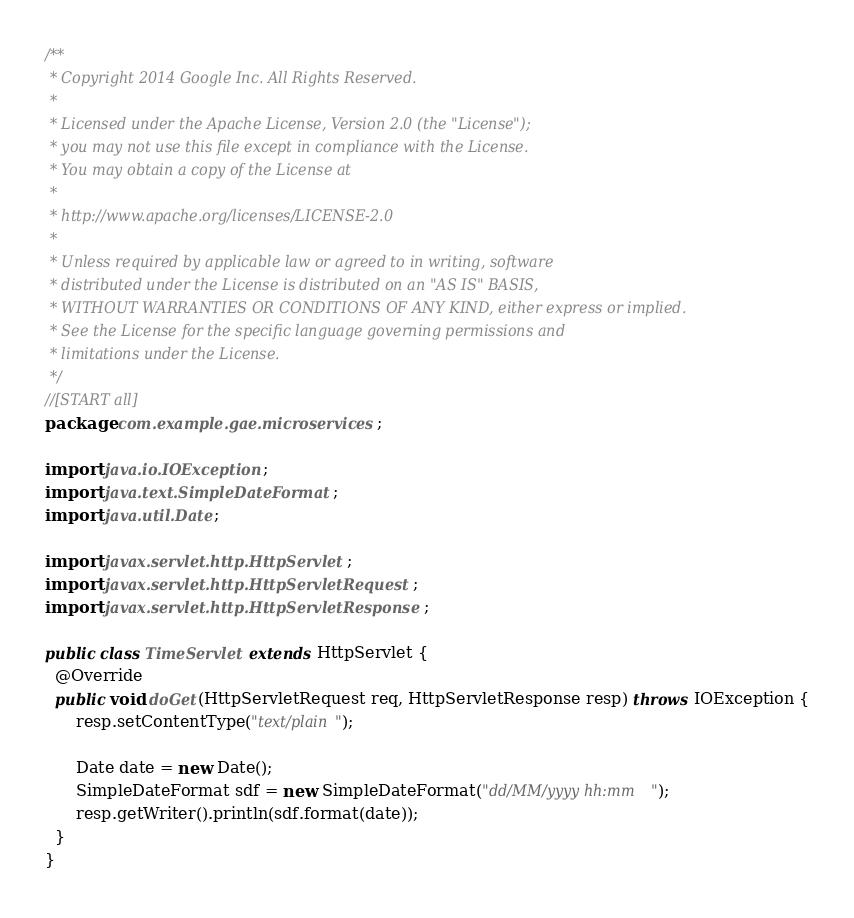<code> <loc_0><loc_0><loc_500><loc_500><_Java_>/**
 * Copyright 2014 Google Inc. All Rights Reserved.
 *
 * Licensed under the Apache License, Version 2.0 (the "License");
 * you may not use this file except in compliance with the License.
 * You may obtain a copy of the License at
 *
 * http://www.apache.org/licenses/LICENSE-2.0
 *
 * Unless required by applicable law or agreed to in writing, software
 * distributed under the License is distributed on an "AS IS" BASIS,
 * WITHOUT WARRANTIES OR CONDITIONS OF ANY KIND, either express or implied.
 * See the License for the specific language governing permissions and
 * limitations under the License.
 */
//[START all]
package com.example.gae.microservices;

import java.io.IOException;
import java.text.SimpleDateFormat;
import java.util.Date;

import javax.servlet.http.HttpServlet;
import javax.servlet.http.HttpServletRequest;
import javax.servlet.http.HttpServletResponse;

public class TimeServlet extends HttpServlet {
  @Override
  public void doGet(HttpServletRequest req, HttpServletResponse resp) throws IOException {
      resp.setContentType("text/plain");

      Date date = new Date();
      SimpleDateFormat sdf = new SimpleDateFormat("dd/MM/yyyy hh:mm");
      resp.getWriter().println(sdf.format(date));
  }
}
</code> 